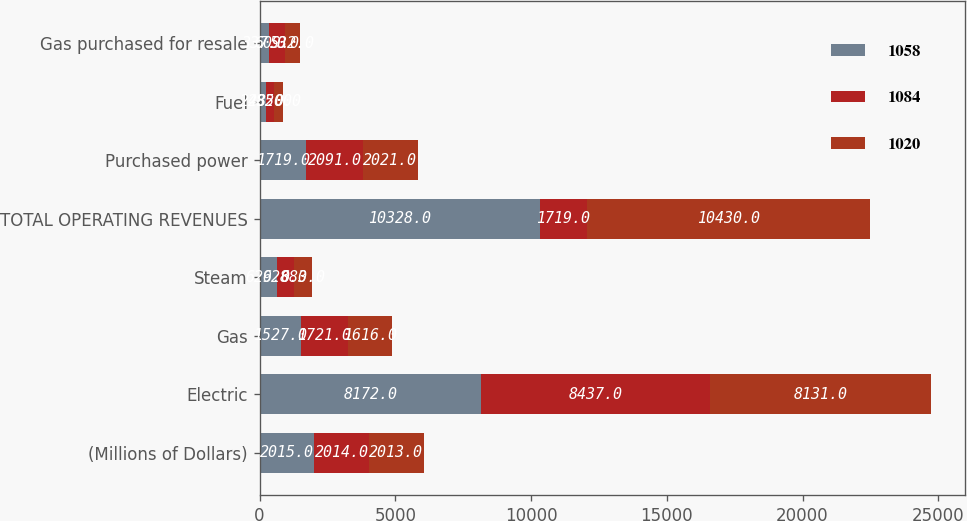Convert chart. <chart><loc_0><loc_0><loc_500><loc_500><stacked_bar_chart><ecel><fcel>(Millions of Dollars)<fcel>Electric<fcel>Gas<fcel>Steam<fcel>TOTAL OPERATING REVENUES<fcel>Purchased power<fcel>Fuel<fcel>Gas purchased for resale<nl><fcel>1058<fcel>2015<fcel>8172<fcel>1527<fcel>629<fcel>10328<fcel>1719<fcel>248<fcel>337<nl><fcel>1084<fcel>2014<fcel>8437<fcel>1721<fcel>628<fcel>1719<fcel>2091<fcel>285<fcel>609<nl><fcel>1020<fcel>2013<fcel>8131<fcel>1616<fcel>683<fcel>10430<fcel>2021<fcel>320<fcel>532<nl></chart> 